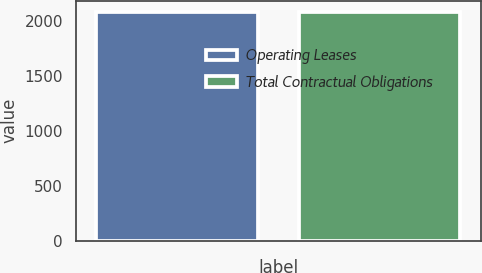Convert chart to OTSL. <chart><loc_0><loc_0><loc_500><loc_500><bar_chart><fcel>Operating Leases<fcel>Total Contractual Obligations<nl><fcel>2079<fcel>2079.1<nl></chart> 